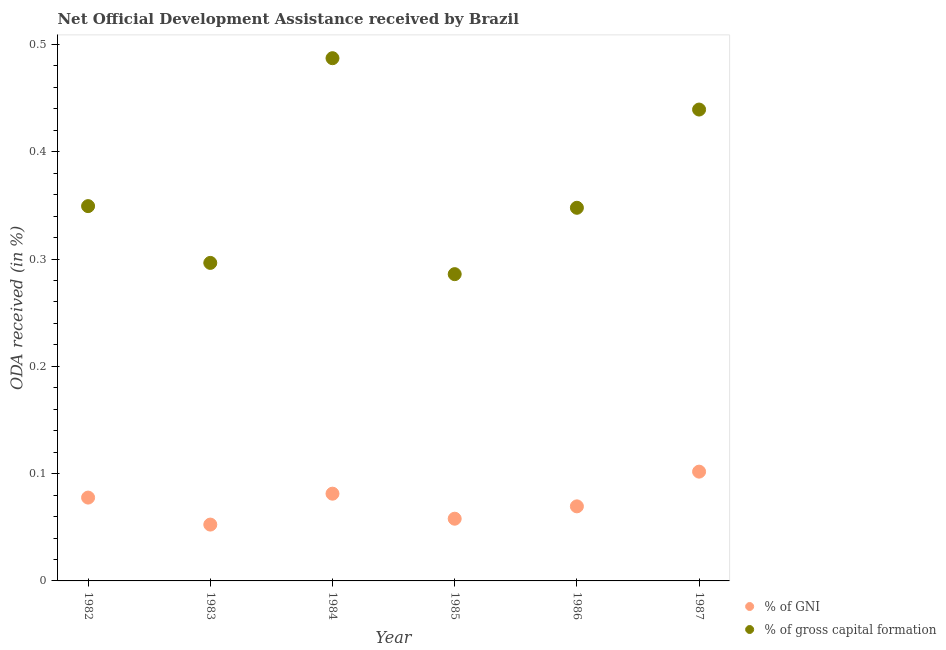Is the number of dotlines equal to the number of legend labels?
Keep it short and to the point. Yes. What is the oda received as percentage of gni in 1985?
Provide a short and direct response. 0.06. Across all years, what is the maximum oda received as percentage of gni?
Your response must be concise. 0.1. Across all years, what is the minimum oda received as percentage of gni?
Make the answer very short. 0.05. In which year was the oda received as percentage of gni minimum?
Provide a short and direct response. 1983. What is the total oda received as percentage of gni in the graph?
Ensure brevity in your answer.  0.44. What is the difference between the oda received as percentage of gross capital formation in 1985 and that in 1986?
Your response must be concise. -0.06. What is the difference between the oda received as percentage of gross capital formation in 1983 and the oda received as percentage of gni in 1984?
Offer a very short reply. 0.22. What is the average oda received as percentage of gni per year?
Provide a succinct answer. 0.07. In the year 1987, what is the difference between the oda received as percentage of gross capital formation and oda received as percentage of gni?
Your answer should be very brief. 0.34. What is the ratio of the oda received as percentage of gni in 1984 to that in 1987?
Make the answer very short. 0.8. Is the oda received as percentage of gni in 1982 less than that in 1984?
Provide a short and direct response. Yes. Is the difference between the oda received as percentage of gni in 1983 and 1987 greater than the difference between the oda received as percentage of gross capital formation in 1983 and 1987?
Provide a short and direct response. Yes. What is the difference between the highest and the second highest oda received as percentage of gni?
Offer a terse response. 0.02. What is the difference between the highest and the lowest oda received as percentage of gross capital formation?
Offer a very short reply. 0.2. How many years are there in the graph?
Offer a terse response. 6. What is the difference between two consecutive major ticks on the Y-axis?
Provide a succinct answer. 0.1. Are the values on the major ticks of Y-axis written in scientific E-notation?
Ensure brevity in your answer.  No. Does the graph contain grids?
Your answer should be very brief. No. Where does the legend appear in the graph?
Your answer should be very brief. Bottom right. How many legend labels are there?
Make the answer very short. 2. What is the title of the graph?
Make the answer very short. Net Official Development Assistance received by Brazil. Does "Quality of trade" appear as one of the legend labels in the graph?
Your answer should be very brief. No. What is the label or title of the Y-axis?
Provide a short and direct response. ODA received (in %). What is the ODA received (in %) in % of GNI in 1982?
Give a very brief answer. 0.08. What is the ODA received (in %) of % of gross capital formation in 1982?
Provide a short and direct response. 0.35. What is the ODA received (in %) of % of GNI in 1983?
Give a very brief answer. 0.05. What is the ODA received (in %) in % of gross capital formation in 1983?
Ensure brevity in your answer.  0.3. What is the ODA received (in %) in % of GNI in 1984?
Provide a succinct answer. 0.08. What is the ODA received (in %) of % of gross capital formation in 1984?
Provide a succinct answer. 0.49. What is the ODA received (in %) of % of GNI in 1985?
Provide a short and direct response. 0.06. What is the ODA received (in %) in % of gross capital formation in 1985?
Your response must be concise. 0.29. What is the ODA received (in %) of % of GNI in 1986?
Provide a short and direct response. 0.07. What is the ODA received (in %) of % of gross capital formation in 1986?
Offer a very short reply. 0.35. What is the ODA received (in %) of % of GNI in 1987?
Give a very brief answer. 0.1. What is the ODA received (in %) in % of gross capital formation in 1987?
Ensure brevity in your answer.  0.44. Across all years, what is the maximum ODA received (in %) in % of GNI?
Your answer should be very brief. 0.1. Across all years, what is the maximum ODA received (in %) in % of gross capital formation?
Make the answer very short. 0.49. Across all years, what is the minimum ODA received (in %) in % of GNI?
Provide a short and direct response. 0.05. Across all years, what is the minimum ODA received (in %) in % of gross capital formation?
Offer a terse response. 0.29. What is the total ODA received (in %) of % of GNI in the graph?
Provide a short and direct response. 0.44. What is the total ODA received (in %) in % of gross capital formation in the graph?
Keep it short and to the point. 2.21. What is the difference between the ODA received (in %) in % of GNI in 1982 and that in 1983?
Offer a very short reply. 0.03. What is the difference between the ODA received (in %) of % of gross capital formation in 1982 and that in 1983?
Offer a very short reply. 0.05. What is the difference between the ODA received (in %) of % of GNI in 1982 and that in 1984?
Provide a succinct answer. -0. What is the difference between the ODA received (in %) in % of gross capital formation in 1982 and that in 1984?
Make the answer very short. -0.14. What is the difference between the ODA received (in %) of % of GNI in 1982 and that in 1985?
Keep it short and to the point. 0.02. What is the difference between the ODA received (in %) of % of gross capital formation in 1982 and that in 1985?
Your answer should be very brief. 0.06. What is the difference between the ODA received (in %) of % of GNI in 1982 and that in 1986?
Your response must be concise. 0.01. What is the difference between the ODA received (in %) of % of gross capital formation in 1982 and that in 1986?
Offer a very short reply. 0. What is the difference between the ODA received (in %) of % of GNI in 1982 and that in 1987?
Your response must be concise. -0.02. What is the difference between the ODA received (in %) of % of gross capital formation in 1982 and that in 1987?
Provide a succinct answer. -0.09. What is the difference between the ODA received (in %) of % of GNI in 1983 and that in 1984?
Your answer should be very brief. -0.03. What is the difference between the ODA received (in %) in % of gross capital formation in 1983 and that in 1984?
Your answer should be very brief. -0.19. What is the difference between the ODA received (in %) of % of GNI in 1983 and that in 1985?
Offer a terse response. -0.01. What is the difference between the ODA received (in %) in % of gross capital formation in 1983 and that in 1985?
Offer a very short reply. 0.01. What is the difference between the ODA received (in %) in % of GNI in 1983 and that in 1986?
Provide a short and direct response. -0.02. What is the difference between the ODA received (in %) of % of gross capital formation in 1983 and that in 1986?
Offer a terse response. -0.05. What is the difference between the ODA received (in %) in % of GNI in 1983 and that in 1987?
Give a very brief answer. -0.05. What is the difference between the ODA received (in %) of % of gross capital formation in 1983 and that in 1987?
Your answer should be very brief. -0.14. What is the difference between the ODA received (in %) in % of GNI in 1984 and that in 1985?
Your answer should be compact. 0.02. What is the difference between the ODA received (in %) in % of gross capital formation in 1984 and that in 1985?
Give a very brief answer. 0.2. What is the difference between the ODA received (in %) of % of GNI in 1984 and that in 1986?
Your answer should be compact. 0.01. What is the difference between the ODA received (in %) in % of gross capital formation in 1984 and that in 1986?
Your answer should be very brief. 0.14. What is the difference between the ODA received (in %) of % of GNI in 1984 and that in 1987?
Keep it short and to the point. -0.02. What is the difference between the ODA received (in %) of % of gross capital formation in 1984 and that in 1987?
Offer a terse response. 0.05. What is the difference between the ODA received (in %) of % of GNI in 1985 and that in 1986?
Keep it short and to the point. -0.01. What is the difference between the ODA received (in %) of % of gross capital formation in 1985 and that in 1986?
Your response must be concise. -0.06. What is the difference between the ODA received (in %) in % of GNI in 1985 and that in 1987?
Offer a very short reply. -0.04. What is the difference between the ODA received (in %) of % of gross capital formation in 1985 and that in 1987?
Give a very brief answer. -0.15. What is the difference between the ODA received (in %) of % of GNI in 1986 and that in 1987?
Ensure brevity in your answer.  -0.03. What is the difference between the ODA received (in %) of % of gross capital formation in 1986 and that in 1987?
Your response must be concise. -0.09. What is the difference between the ODA received (in %) of % of GNI in 1982 and the ODA received (in %) of % of gross capital formation in 1983?
Your response must be concise. -0.22. What is the difference between the ODA received (in %) in % of GNI in 1982 and the ODA received (in %) in % of gross capital formation in 1984?
Provide a short and direct response. -0.41. What is the difference between the ODA received (in %) in % of GNI in 1982 and the ODA received (in %) in % of gross capital formation in 1985?
Keep it short and to the point. -0.21. What is the difference between the ODA received (in %) in % of GNI in 1982 and the ODA received (in %) in % of gross capital formation in 1986?
Offer a very short reply. -0.27. What is the difference between the ODA received (in %) in % of GNI in 1982 and the ODA received (in %) in % of gross capital formation in 1987?
Offer a terse response. -0.36. What is the difference between the ODA received (in %) in % of GNI in 1983 and the ODA received (in %) in % of gross capital formation in 1984?
Offer a very short reply. -0.43. What is the difference between the ODA received (in %) in % of GNI in 1983 and the ODA received (in %) in % of gross capital formation in 1985?
Provide a succinct answer. -0.23. What is the difference between the ODA received (in %) of % of GNI in 1983 and the ODA received (in %) of % of gross capital formation in 1986?
Your answer should be compact. -0.3. What is the difference between the ODA received (in %) in % of GNI in 1983 and the ODA received (in %) in % of gross capital formation in 1987?
Ensure brevity in your answer.  -0.39. What is the difference between the ODA received (in %) of % of GNI in 1984 and the ODA received (in %) of % of gross capital formation in 1985?
Offer a terse response. -0.2. What is the difference between the ODA received (in %) of % of GNI in 1984 and the ODA received (in %) of % of gross capital formation in 1986?
Offer a very short reply. -0.27. What is the difference between the ODA received (in %) of % of GNI in 1984 and the ODA received (in %) of % of gross capital formation in 1987?
Your answer should be very brief. -0.36. What is the difference between the ODA received (in %) in % of GNI in 1985 and the ODA received (in %) in % of gross capital formation in 1986?
Ensure brevity in your answer.  -0.29. What is the difference between the ODA received (in %) of % of GNI in 1985 and the ODA received (in %) of % of gross capital formation in 1987?
Your response must be concise. -0.38. What is the difference between the ODA received (in %) in % of GNI in 1986 and the ODA received (in %) in % of gross capital formation in 1987?
Provide a short and direct response. -0.37. What is the average ODA received (in %) of % of GNI per year?
Make the answer very short. 0.07. What is the average ODA received (in %) of % of gross capital formation per year?
Give a very brief answer. 0.37. In the year 1982, what is the difference between the ODA received (in %) in % of GNI and ODA received (in %) in % of gross capital formation?
Provide a succinct answer. -0.27. In the year 1983, what is the difference between the ODA received (in %) of % of GNI and ODA received (in %) of % of gross capital formation?
Give a very brief answer. -0.24. In the year 1984, what is the difference between the ODA received (in %) of % of GNI and ODA received (in %) of % of gross capital formation?
Your answer should be compact. -0.41. In the year 1985, what is the difference between the ODA received (in %) of % of GNI and ODA received (in %) of % of gross capital formation?
Keep it short and to the point. -0.23. In the year 1986, what is the difference between the ODA received (in %) in % of GNI and ODA received (in %) in % of gross capital formation?
Your response must be concise. -0.28. In the year 1987, what is the difference between the ODA received (in %) of % of GNI and ODA received (in %) of % of gross capital formation?
Make the answer very short. -0.34. What is the ratio of the ODA received (in %) in % of GNI in 1982 to that in 1983?
Your answer should be very brief. 1.48. What is the ratio of the ODA received (in %) in % of gross capital formation in 1982 to that in 1983?
Provide a succinct answer. 1.18. What is the ratio of the ODA received (in %) of % of GNI in 1982 to that in 1984?
Keep it short and to the point. 0.96. What is the ratio of the ODA received (in %) of % of gross capital formation in 1982 to that in 1984?
Provide a short and direct response. 0.72. What is the ratio of the ODA received (in %) in % of GNI in 1982 to that in 1985?
Make the answer very short. 1.34. What is the ratio of the ODA received (in %) in % of gross capital formation in 1982 to that in 1985?
Your answer should be very brief. 1.22. What is the ratio of the ODA received (in %) of % of GNI in 1982 to that in 1986?
Give a very brief answer. 1.12. What is the ratio of the ODA received (in %) of % of gross capital formation in 1982 to that in 1986?
Your answer should be compact. 1. What is the ratio of the ODA received (in %) in % of GNI in 1982 to that in 1987?
Ensure brevity in your answer.  0.76. What is the ratio of the ODA received (in %) of % of gross capital formation in 1982 to that in 1987?
Your answer should be compact. 0.8. What is the ratio of the ODA received (in %) of % of GNI in 1983 to that in 1984?
Offer a very short reply. 0.65. What is the ratio of the ODA received (in %) in % of gross capital formation in 1983 to that in 1984?
Ensure brevity in your answer.  0.61. What is the ratio of the ODA received (in %) in % of GNI in 1983 to that in 1985?
Provide a short and direct response. 0.91. What is the ratio of the ODA received (in %) of % of gross capital formation in 1983 to that in 1985?
Give a very brief answer. 1.04. What is the ratio of the ODA received (in %) in % of GNI in 1983 to that in 1986?
Offer a terse response. 0.76. What is the ratio of the ODA received (in %) in % of gross capital formation in 1983 to that in 1986?
Provide a short and direct response. 0.85. What is the ratio of the ODA received (in %) in % of GNI in 1983 to that in 1987?
Your response must be concise. 0.52. What is the ratio of the ODA received (in %) in % of gross capital formation in 1983 to that in 1987?
Give a very brief answer. 0.67. What is the ratio of the ODA received (in %) of % of GNI in 1984 to that in 1985?
Provide a succinct answer. 1.4. What is the ratio of the ODA received (in %) of % of gross capital formation in 1984 to that in 1985?
Offer a terse response. 1.7. What is the ratio of the ODA received (in %) of % of GNI in 1984 to that in 1986?
Ensure brevity in your answer.  1.17. What is the ratio of the ODA received (in %) in % of gross capital formation in 1984 to that in 1986?
Offer a terse response. 1.4. What is the ratio of the ODA received (in %) of % of GNI in 1984 to that in 1987?
Ensure brevity in your answer.  0.8. What is the ratio of the ODA received (in %) in % of gross capital formation in 1984 to that in 1987?
Give a very brief answer. 1.11. What is the ratio of the ODA received (in %) of % of GNI in 1985 to that in 1986?
Offer a terse response. 0.83. What is the ratio of the ODA received (in %) in % of gross capital formation in 1985 to that in 1986?
Your answer should be compact. 0.82. What is the ratio of the ODA received (in %) of % of GNI in 1985 to that in 1987?
Provide a succinct answer. 0.57. What is the ratio of the ODA received (in %) of % of gross capital formation in 1985 to that in 1987?
Ensure brevity in your answer.  0.65. What is the ratio of the ODA received (in %) of % of GNI in 1986 to that in 1987?
Make the answer very short. 0.68. What is the ratio of the ODA received (in %) in % of gross capital formation in 1986 to that in 1987?
Provide a succinct answer. 0.79. What is the difference between the highest and the second highest ODA received (in %) of % of GNI?
Keep it short and to the point. 0.02. What is the difference between the highest and the second highest ODA received (in %) in % of gross capital formation?
Your response must be concise. 0.05. What is the difference between the highest and the lowest ODA received (in %) of % of GNI?
Offer a very short reply. 0.05. What is the difference between the highest and the lowest ODA received (in %) in % of gross capital formation?
Your response must be concise. 0.2. 